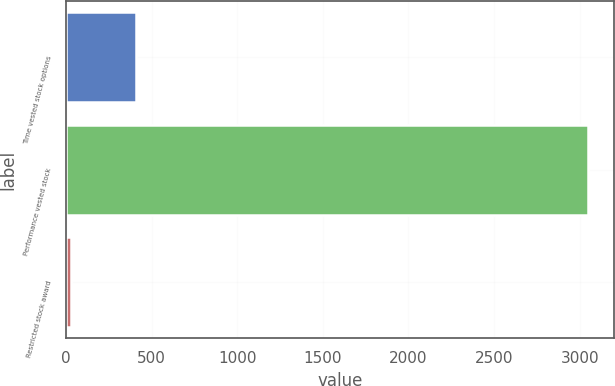<chart> <loc_0><loc_0><loc_500><loc_500><bar_chart><fcel>Time vested stock options<fcel>Performance vested stock<fcel>Restricted stock award<nl><fcel>408<fcel>3047<fcel>32<nl></chart> 